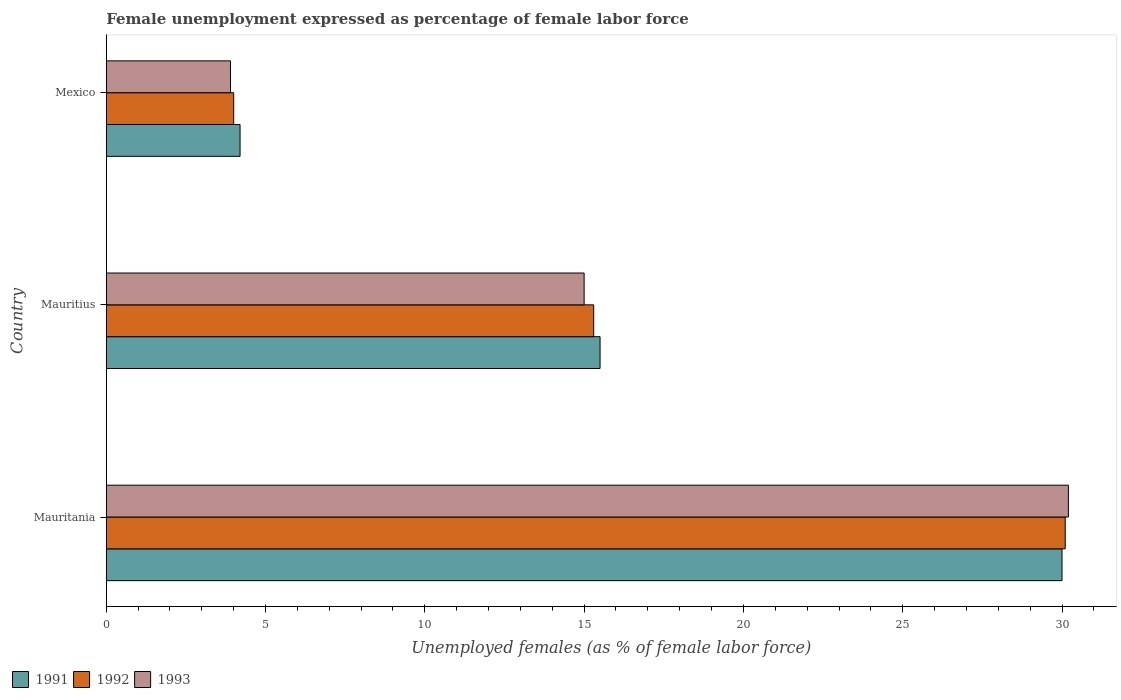How many different coloured bars are there?
Keep it short and to the point. 3. How many groups of bars are there?
Your answer should be compact. 3. What is the label of the 2nd group of bars from the top?
Offer a very short reply. Mauritius. In how many cases, is the number of bars for a given country not equal to the number of legend labels?
Make the answer very short. 0. What is the unemployment in females in in 1992 in Mauritius?
Keep it short and to the point. 15.3. Across all countries, what is the maximum unemployment in females in in 1992?
Your answer should be compact. 30.1. Across all countries, what is the minimum unemployment in females in in 1993?
Give a very brief answer. 3.9. In which country was the unemployment in females in in 1993 maximum?
Provide a short and direct response. Mauritania. What is the total unemployment in females in in 1993 in the graph?
Ensure brevity in your answer.  49.1. What is the difference between the unemployment in females in in 1991 in Mauritius and that in Mexico?
Offer a very short reply. 11.3. What is the difference between the unemployment in females in in 1992 in Mauritius and the unemployment in females in in 1993 in Mexico?
Provide a succinct answer. 11.4. What is the average unemployment in females in in 1991 per country?
Offer a very short reply. 16.57. What is the difference between the unemployment in females in in 1991 and unemployment in females in in 1992 in Mauritius?
Your response must be concise. 0.2. In how many countries, is the unemployment in females in in 1992 greater than 10 %?
Provide a succinct answer. 2. What is the ratio of the unemployment in females in in 1991 in Mauritania to that in Mauritius?
Give a very brief answer. 1.94. Is the unemployment in females in in 1992 in Mauritania less than that in Mexico?
Ensure brevity in your answer.  No. What is the difference between the highest and the second highest unemployment in females in in 1991?
Your answer should be compact. 14.5. What is the difference between the highest and the lowest unemployment in females in in 1991?
Your answer should be compact. 25.8. In how many countries, is the unemployment in females in in 1991 greater than the average unemployment in females in in 1991 taken over all countries?
Your response must be concise. 1. Is the sum of the unemployment in females in in 1991 in Mauritius and Mexico greater than the maximum unemployment in females in in 1993 across all countries?
Keep it short and to the point. No. Are all the bars in the graph horizontal?
Give a very brief answer. Yes. How many countries are there in the graph?
Provide a short and direct response. 3. What is the difference between two consecutive major ticks on the X-axis?
Keep it short and to the point. 5. How are the legend labels stacked?
Make the answer very short. Horizontal. What is the title of the graph?
Your answer should be compact. Female unemployment expressed as percentage of female labor force. Does "2007" appear as one of the legend labels in the graph?
Your response must be concise. No. What is the label or title of the X-axis?
Offer a very short reply. Unemployed females (as % of female labor force). What is the label or title of the Y-axis?
Ensure brevity in your answer.  Country. What is the Unemployed females (as % of female labor force) of 1992 in Mauritania?
Offer a terse response. 30.1. What is the Unemployed females (as % of female labor force) of 1993 in Mauritania?
Your response must be concise. 30.2. What is the Unemployed females (as % of female labor force) of 1992 in Mauritius?
Provide a short and direct response. 15.3. What is the Unemployed females (as % of female labor force) of 1991 in Mexico?
Provide a short and direct response. 4.2. What is the Unemployed females (as % of female labor force) in 1992 in Mexico?
Your answer should be compact. 4. What is the Unemployed females (as % of female labor force) in 1993 in Mexico?
Your answer should be very brief. 3.9. Across all countries, what is the maximum Unemployed females (as % of female labor force) of 1991?
Give a very brief answer. 30. Across all countries, what is the maximum Unemployed females (as % of female labor force) in 1992?
Offer a very short reply. 30.1. Across all countries, what is the maximum Unemployed females (as % of female labor force) in 1993?
Offer a terse response. 30.2. Across all countries, what is the minimum Unemployed females (as % of female labor force) in 1991?
Your answer should be very brief. 4.2. Across all countries, what is the minimum Unemployed females (as % of female labor force) in 1993?
Make the answer very short. 3.9. What is the total Unemployed females (as % of female labor force) in 1991 in the graph?
Your answer should be very brief. 49.7. What is the total Unemployed females (as % of female labor force) of 1992 in the graph?
Make the answer very short. 49.4. What is the total Unemployed females (as % of female labor force) of 1993 in the graph?
Ensure brevity in your answer.  49.1. What is the difference between the Unemployed females (as % of female labor force) of 1991 in Mauritania and that in Mauritius?
Offer a very short reply. 14.5. What is the difference between the Unemployed females (as % of female labor force) in 1992 in Mauritania and that in Mauritius?
Your answer should be compact. 14.8. What is the difference between the Unemployed females (as % of female labor force) of 1991 in Mauritania and that in Mexico?
Provide a short and direct response. 25.8. What is the difference between the Unemployed females (as % of female labor force) in 1992 in Mauritania and that in Mexico?
Offer a very short reply. 26.1. What is the difference between the Unemployed females (as % of female labor force) of 1993 in Mauritania and that in Mexico?
Ensure brevity in your answer.  26.3. What is the difference between the Unemployed females (as % of female labor force) of 1992 in Mauritius and that in Mexico?
Your answer should be very brief. 11.3. What is the difference between the Unemployed females (as % of female labor force) of 1991 in Mauritania and the Unemployed females (as % of female labor force) of 1992 in Mauritius?
Keep it short and to the point. 14.7. What is the difference between the Unemployed females (as % of female labor force) of 1992 in Mauritania and the Unemployed females (as % of female labor force) of 1993 in Mauritius?
Your response must be concise. 15.1. What is the difference between the Unemployed females (as % of female labor force) in 1991 in Mauritania and the Unemployed females (as % of female labor force) in 1992 in Mexico?
Your response must be concise. 26. What is the difference between the Unemployed females (as % of female labor force) in 1991 in Mauritania and the Unemployed females (as % of female labor force) in 1993 in Mexico?
Your answer should be compact. 26.1. What is the difference between the Unemployed females (as % of female labor force) in 1992 in Mauritania and the Unemployed females (as % of female labor force) in 1993 in Mexico?
Provide a succinct answer. 26.2. What is the difference between the Unemployed females (as % of female labor force) in 1991 in Mauritius and the Unemployed females (as % of female labor force) in 1992 in Mexico?
Offer a terse response. 11.5. What is the average Unemployed females (as % of female labor force) in 1991 per country?
Make the answer very short. 16.57. What is the average Unemployed females (as % of female labor force) of 1992 per country?
Your response must be concise. 16.47. What is the average Unemployed females (as % of female labor force) in 1993 per country?
Your response must be concise. 16.37. What is the difference between the Unemployed females (as % of female labor force) in 1991 and Unemployed females (as % of female labor force) in 1992 in Mauritania?
Provide a succinct answer. -0.1. What is the ratio of the Unemployed females (as % of female labor force) in 1991 in Mauritania to that in Mauritius?
Your answer should be compact. 1.94. What is the ratio of the Unemployed females (as % of female labor force) of 1992 in Mauritania to that in Mauritius?
Provide a short and direct response. 1.97. What is the ratio of the Unemployed females (as % of female labor force) in 1993 in Mauritania to that in Mauritius?
Ensure brevity in your answer.  2.01. What is the ratio of the Unemployed females (as % of female labor force) in 1991 in Mauritania to that in Mexico?
Provide a succinct answer. 7.14. What is the ratio of the Unemployed females (as % of female labor force) of 1992 in Mauritania to that in Mexico?
Your answer should be compact. 7.53. What is the ratio of the Unemployed females (as % of female labor force) in 1993 in Mauritania to that in Mexico?
Offer a very short reply. 7.74. What is the ratio of the Unemployed females (as % of female labor force) of 1991 in Mauritius to that in Mexico?
Ensure brevity in your answer.  3.69. What is the ratio of the Unemployed females (as % of female labor force) of 1992 in Mauritius to that in Mexico?
Provide a succinct answer. 3.83. What is the ratio of the Unemployed females (as % of female labor force) in 1993 in Mauritius to that in Mexico?
Keep it short and to the point. 3.85. What is the difference between the highest and the second highest Unemployed females (as % of female labor force) in 1991?
Your answer should be very brief. 14.5. What is the difference between the highest and the second highest Unemployed females (as % of female labor force) in 1992?
Ensure brevity in your answer.  14.8. What is the difference between the highest and the lowest Unemployed females (as % of female labor force) of 1991?
Provide a short and direct response. 25.8. What is the difference between the highest and the lowest Unemployed females (as % of female labor force) of 1992?
Provide a succinct answer. 26.1. What is the difference between the highest and the lowest Unemployed females (as % of female labor force) of 1993?
Ensure brevity in your answer.  26.3. 